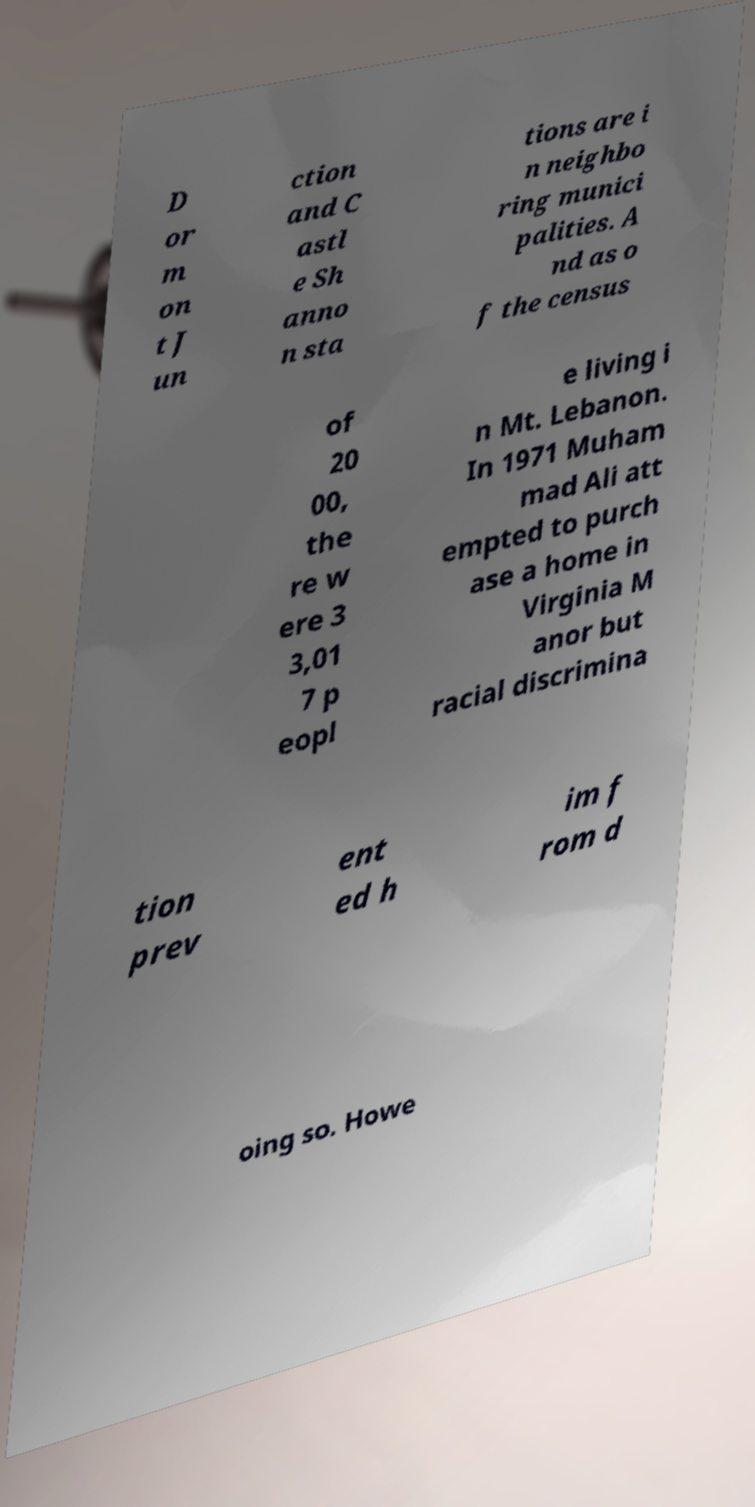There's text embedded in this image that I need extracted. Can you transcribe it verbatim? D or m on t J un ction and C astl e Sh anno n sta tions are i n neighbo ring munici palities. A nd as o f the census of 20 00, the re w ere 3 3,01 7 p eopl e living i n Mt. Lebanon. In 1971 Muham mad Ali att empted to purch ase a home in Virginia M anor but racial discrimina tion prev ent ed h im f rom d oing so. Howe 